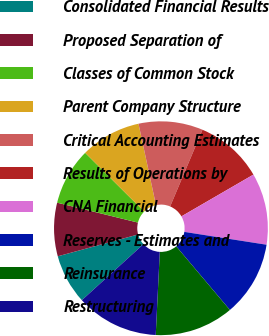Convert chart. <chart><loc_0><loc_0><loc_500><loc_500><pie_chart><fcel>Consolidated Financial Results<fcel>Proposed Separation of<fcel>Classes of Common Stock<fcel>Parent Company Structure<fcel>Critical Accounting Estimates<fcel>Results of Operations by<fcel>CNA Financial<fcel>Reserves - Estimates and<fcel>Reinsurance<fcel>Restructuring<nl><fcel>7.52%<fcel>8.07%<fcel>8.62%<fcel>9.17%<fcel>9.72%<fcel>10.28%<fcel>10.83%<fcel>11.38%<fcel>11.93%<fcel>12.48%<nl></chart> 